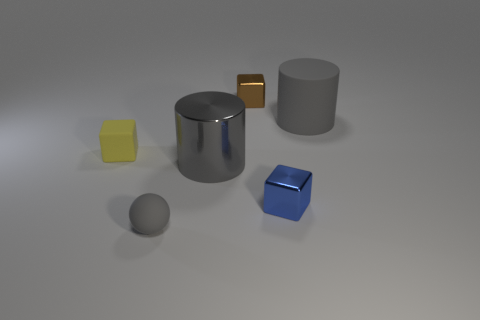The brown object that is the same size as the gray sphere is what shape?
Your response must be concise. Cube. Is the material of the large thing that is right of the gray metal cylinder the same as the tiny blue thing?
Offer a very short reply. No. Are there more rubber things on the right side of the blue metal block than large gray cylinders that are to the left of the small brown shiny block?
Give a very brief answer. No. There is a brown thing that is the same size as the yellow matte object; what is it made of?
Offer a terse response. Metal. What number of other things are the same material as the small blue thing?
Provide a succinct answer. 2. Is the shape of the tiny metallic thing that is behind the shiny cylinder the same as the yellow matte object that is behind the large metal thing?
Offer a very short reply. Yes. How many other things are the same color as the matte cylinder?
Keep it short and to the point. 2. Are the large thing in front of the tiny yellow rubber object and the large gray object that is right of the tiny brown metallic cube made of the same material?
Provide a short and direct response. No. Are there an equal number of gray metallic things that are left of the yellow matte cube and brown things that are right of the small blue object?
Provide a short and direct response. Yes. What material is the big gray cylinder that is on the left side of the brown shiny object?
Provide a short and direct response. Metal. 